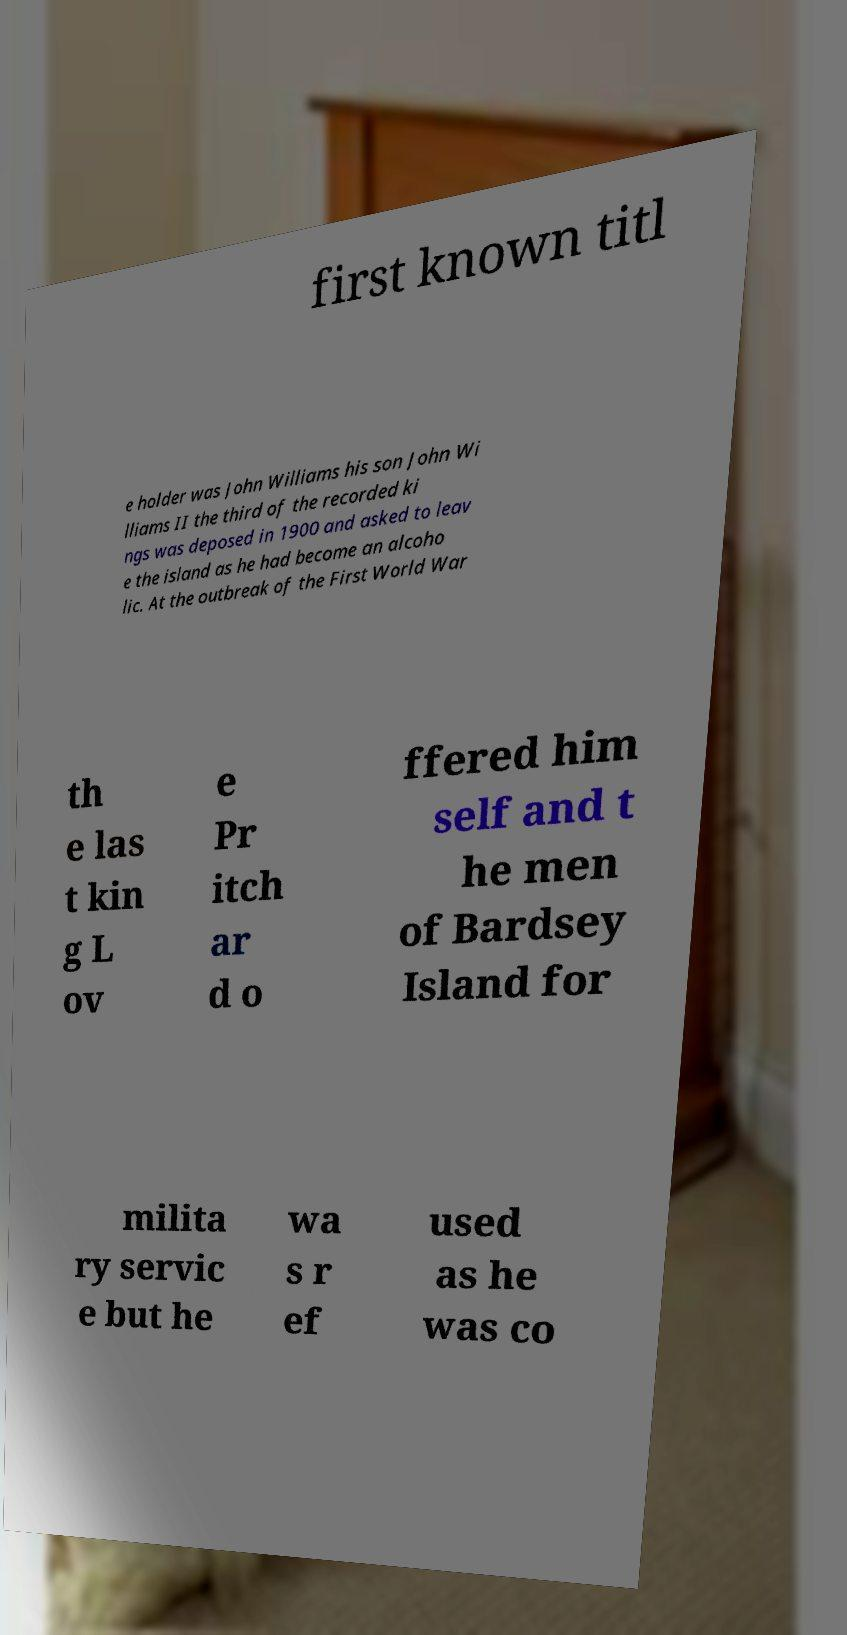For documentation purposes, I need the text within this image transcribed. Could you provide that? first known titl e holder was John Williams his son John Wi lliams II the third of the recorded ki ngs was deposed in 1900 and asked to leav e the island as he had become an alcoho lic. At the outbreak of the First World War th e las t kin g L ov e Pr itch ar d o ffered him self and t he men of Bardsey Island for milita ry servic e but he wa s r ef used as he was co 